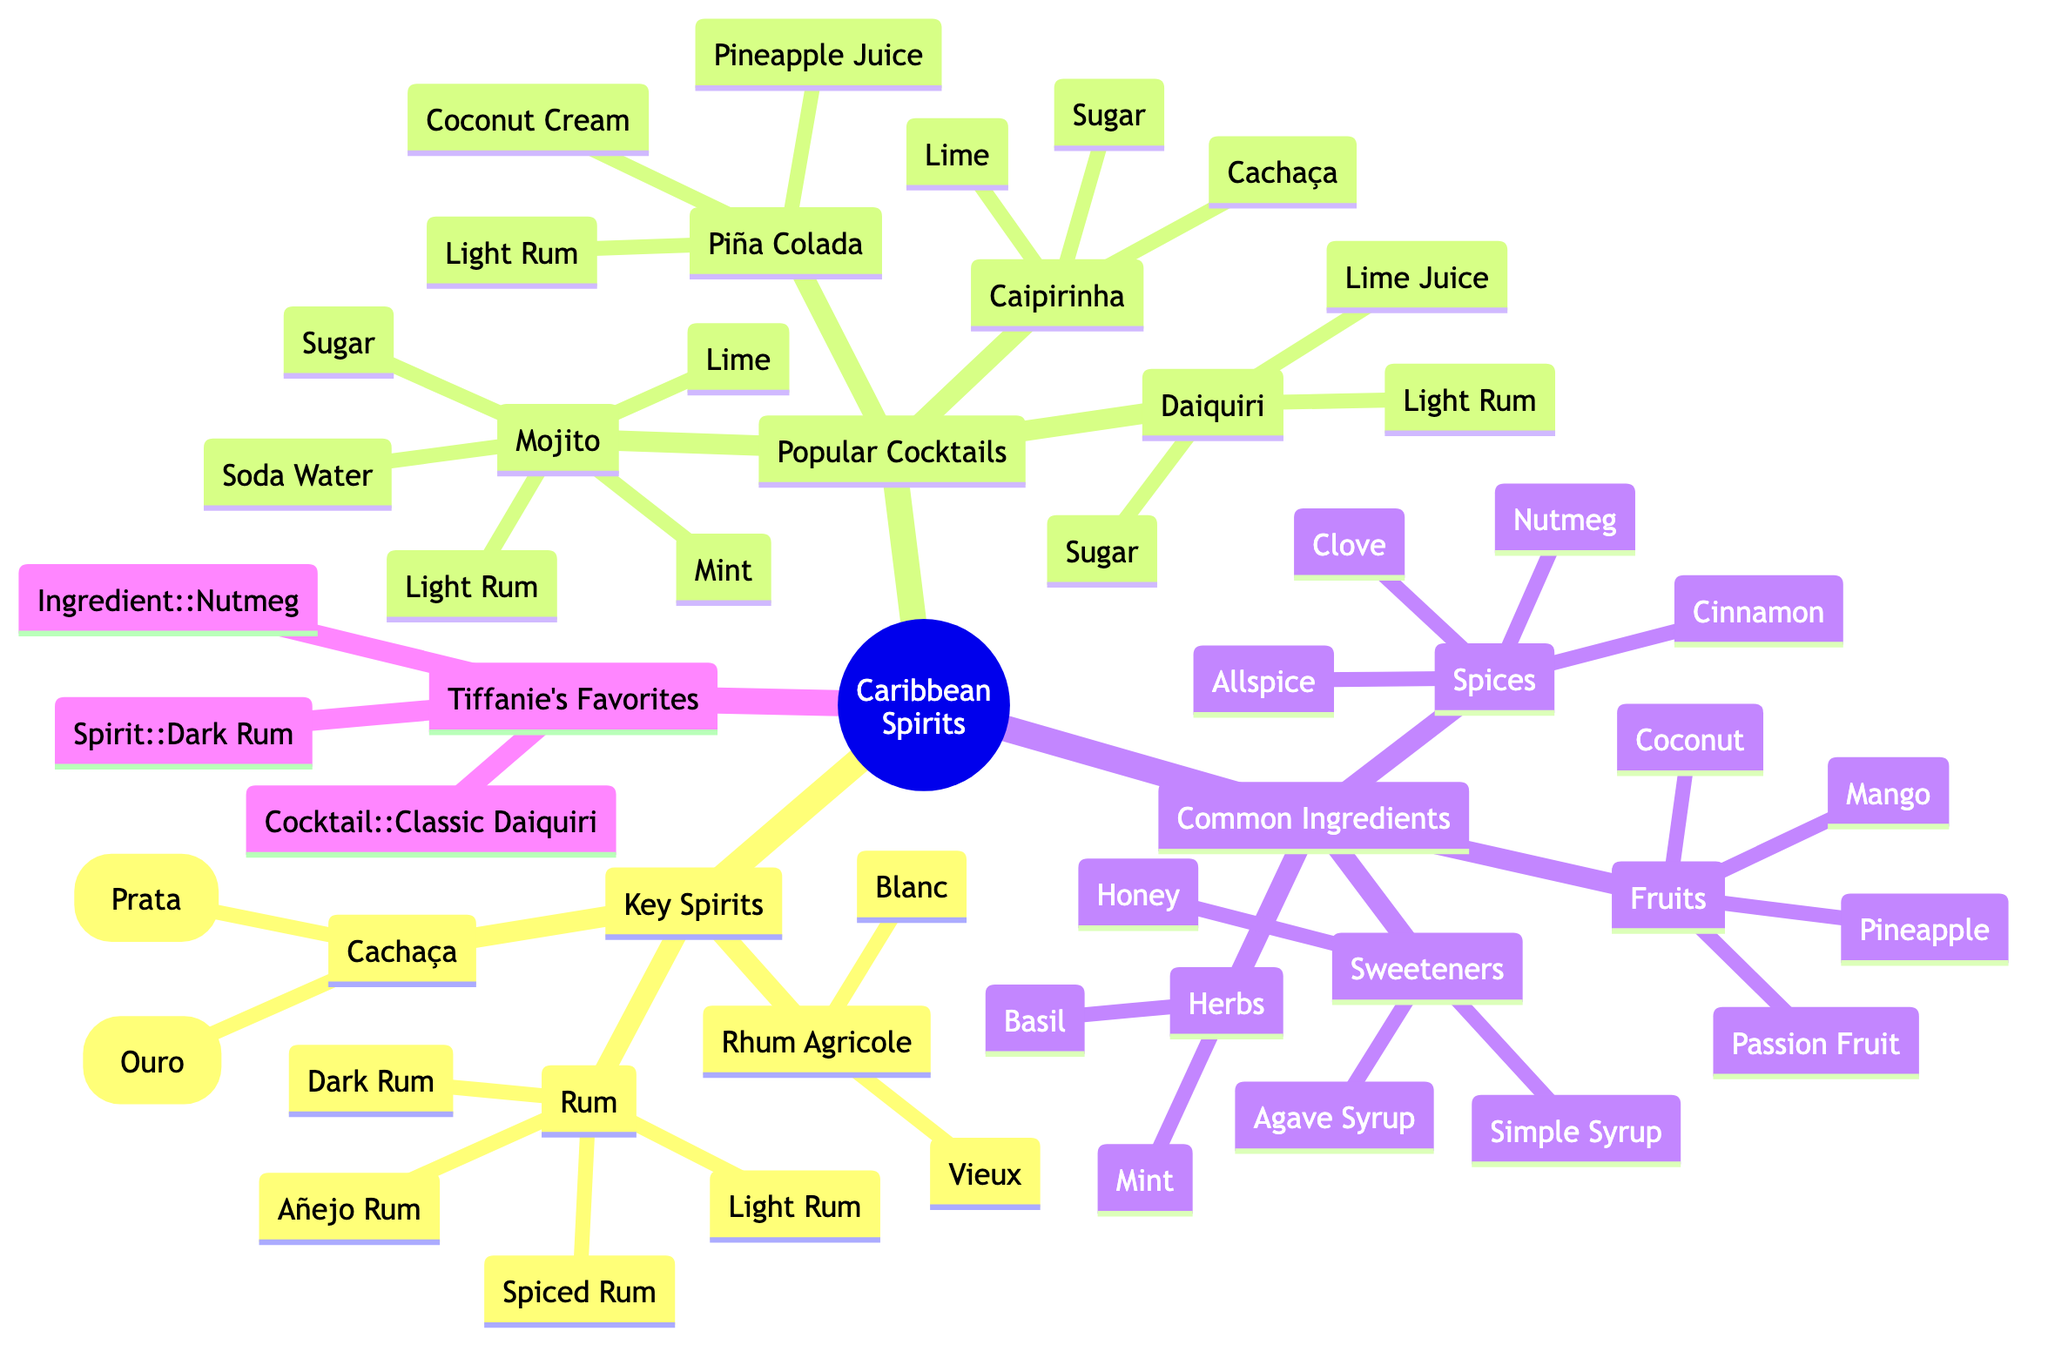What are the key spirits in the diagram? The key spirits are listed directly under the "Key Spirits" node which includes Rum, Rhum Agricole, and Cachaça. These are main categories with specific types listed below them.
Answer: Rum, Rhum Agricole, Cachaça How many types of rum are identified in the diagram? Under the "Rum" node, there are four specific types: Light Rum, Dark Rum, Spiced Rum, and Añejo Rum. Therefore, when counting these types, we arrive at a total of four.
Answer: 4 Which cocktail contains coconut cream? The "Piña Colada" entry under "Popular Cocktails" has "Coconut Cream" listed as one of its ingredients. We find the relationship between the cocktail and its ingredient directly in the nested structure of the mind map.
Answer: Piña Colada What is Tiffanie Barriere's favorite ingredient? In the "Tiffanie Barriere's Favorites" section, the ingredient is explicitly stated as "Nutmeg." We can directly refer to this part of the diagram to get the answer.
Answer: Nutmeg How many common fruit ingredients are listed? The "Common Ingredients" section contains a sub-category for "Fruits," which lists four specific fruits: Mango, Pineapple, Coconut, and Passion Fruit. Thus, counting these gives us the total.
Answer: 4 What spirit is used in Caipirinha? The "Caipirinha" cocktail listed under "Popular Cocktails" identifies "Cachaça" as its primary spirit ingredient. We derive this from the direct association within the mind map.
Answer: Cachaça Which spices are present in the common ingredients? The "Spices" node under "Common Ingredients" lists Cinnamon, Nutmeg, Allspice, and Clove explicitly. We look for the spices categorized there to answer this question.
Answer: Cinnamon, Nutmeg, Allspice, Clove What type of rum is favored by Tiffanie Barriere? The "Spirit" node in "Tiffanie Barriere's Favorites" specifically states "Dark Rum" as her favorite spirit. This information can be directly referenced from that section of the diagram.
Answer: Dark Rum What is the primary ingredient in a Daiquiri? The "Daiquiri" entry under "Popular Cocktails" shows that "Light Rum" is listed as the main ingredient. This can be identified directly from the cocktail's details.
Answer: Light Rum 